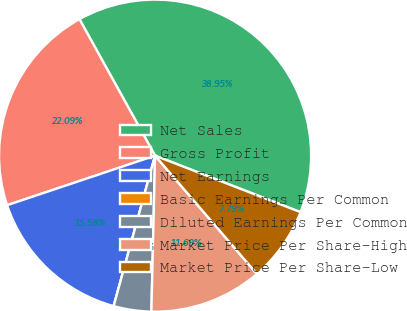Convert chart. <chart><loc_0><loc_0><loc_500><loc_500><pie_chart><fcel>Net Sales<fcel>Gross Profit<fcel>Net Earnings<fcel>Basic Earnings Per Common<fcel>Diluted Earnings Per Common<fcel>Market Price Per Share-High<fcel>Market Price Per Share-Low<nl><fcel>38.95%<fcel>22.09%<fcel>15.58%<fcel>0.0%<fcel>3.9%<fcel>11.69%<fcel>7.79%<nl></chart> 